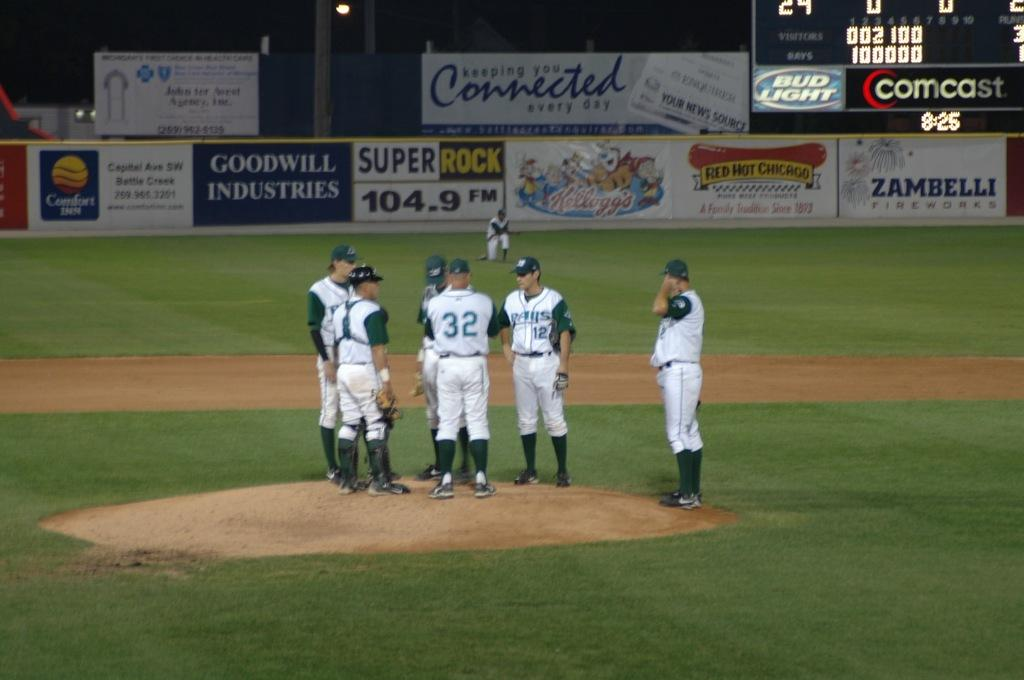<image>
Share a concise interpretation of the image provided. Baseball players converge on the pitcher's mound in front of the outfield fence, which bears an advertisement for Goodwill Industries. 